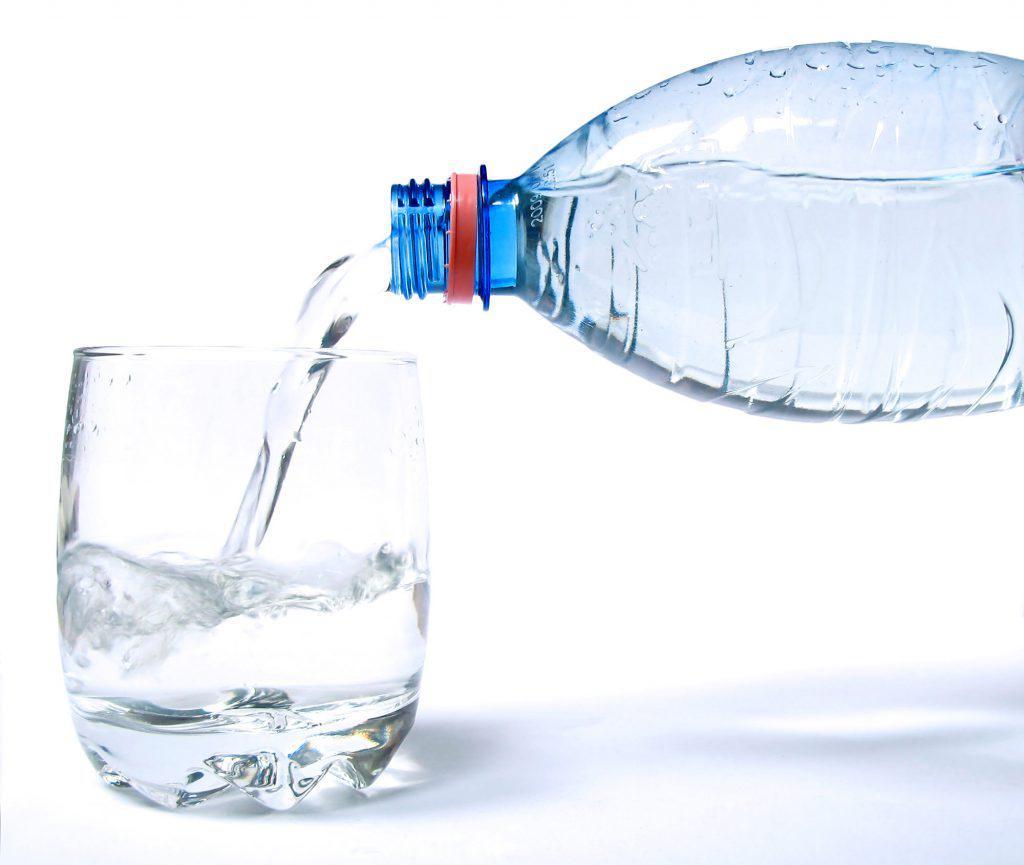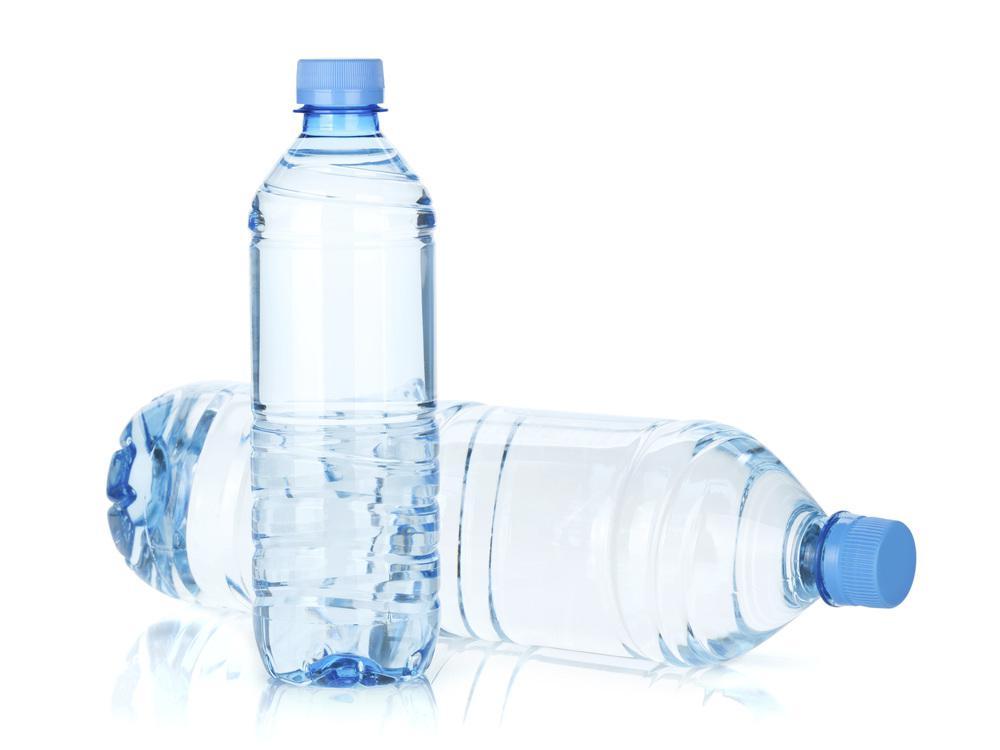The first image is the image on the left, the second image is the image on the right. Evaluate the accuracy of this statement regarding the images: "There is a bottle laying sideways in one of the images.". Is it true? Answer yes or no. Yes. The first image is the image on the left, the second image is the image on the right. For the images shown, is this caption "An image shows an upright water bottle next to one lying on its side." true? Answer yes or no. Yes. 